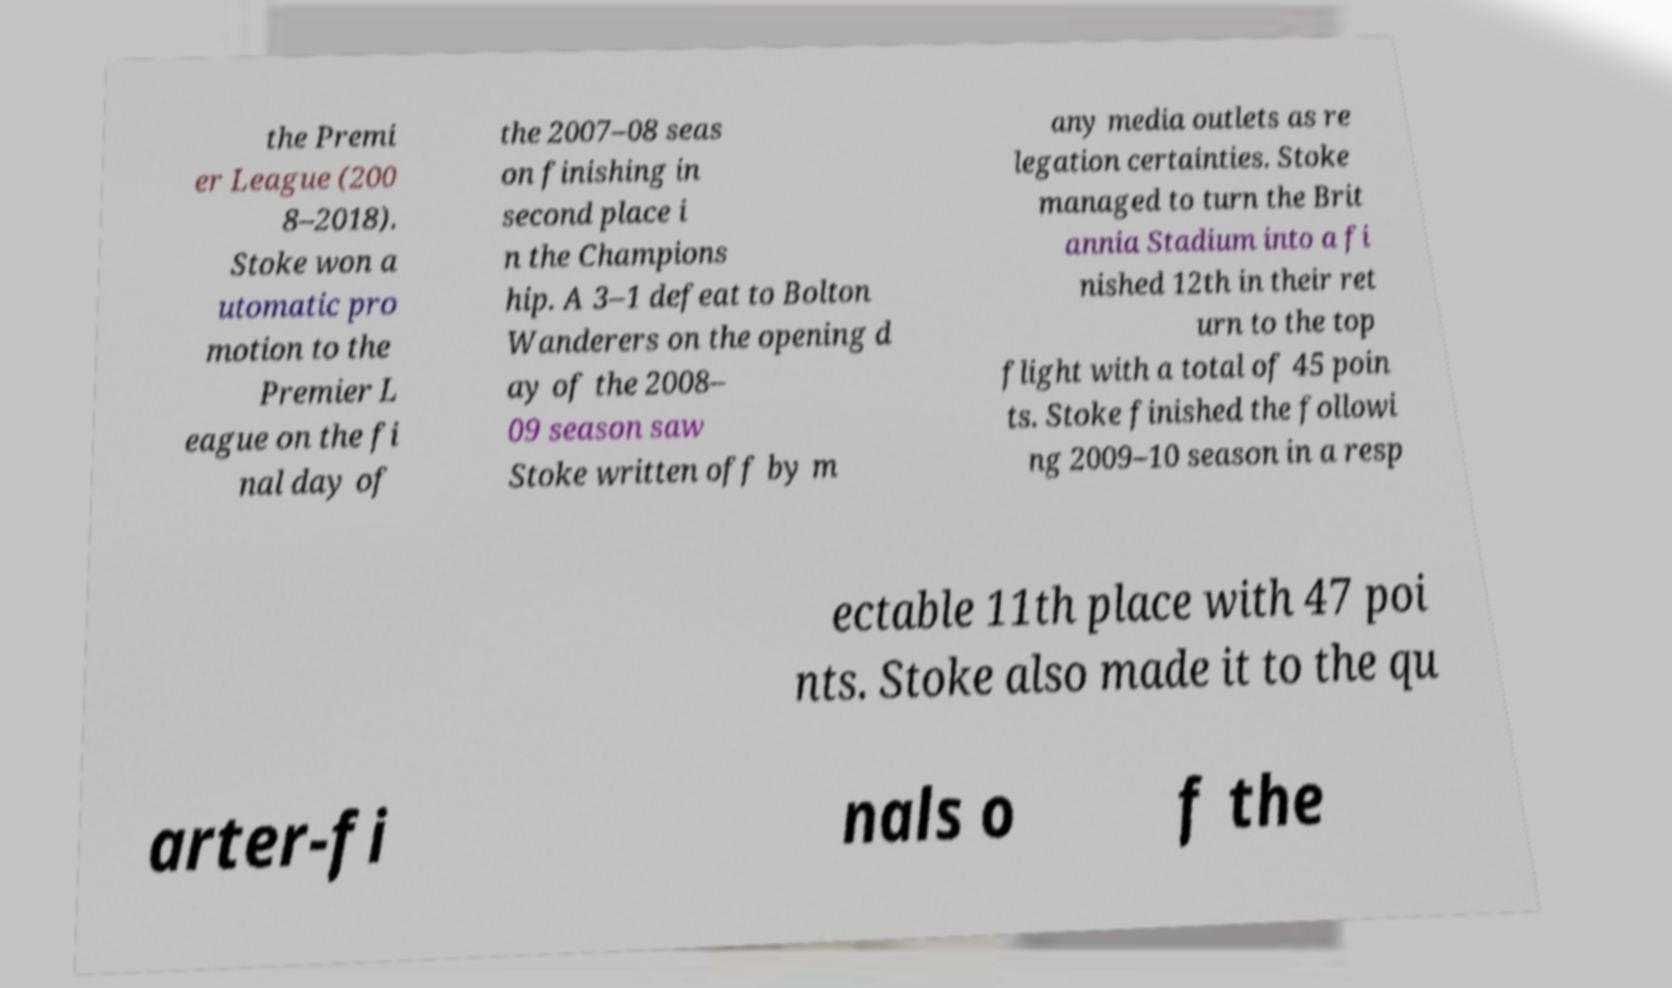What messages or text are displayed in this image? I need them in a readable, typed format. the Premi er League (200 8–2018). Stoke won a utomatic pro motion to the Premier L eague on the fi nal day of the 2007–08 seas on finishing in second place i n the Champions hip. A 3–1 defeat to Bolton Wanderers on the opening d ay of the 2008– 09 season saw Stoke written off by m any media outlets as re legation certainties. Stoke managed to turn the Brit annia Stadium into a fi nished 12th in their ret urn to the top flight with a total of 45 poin ts. Stoke finished the followi ng 2009–10 season in a resp ectable 11th place with 47 poi nts. Stoke also made it to the qu arter-fi nals o f the 